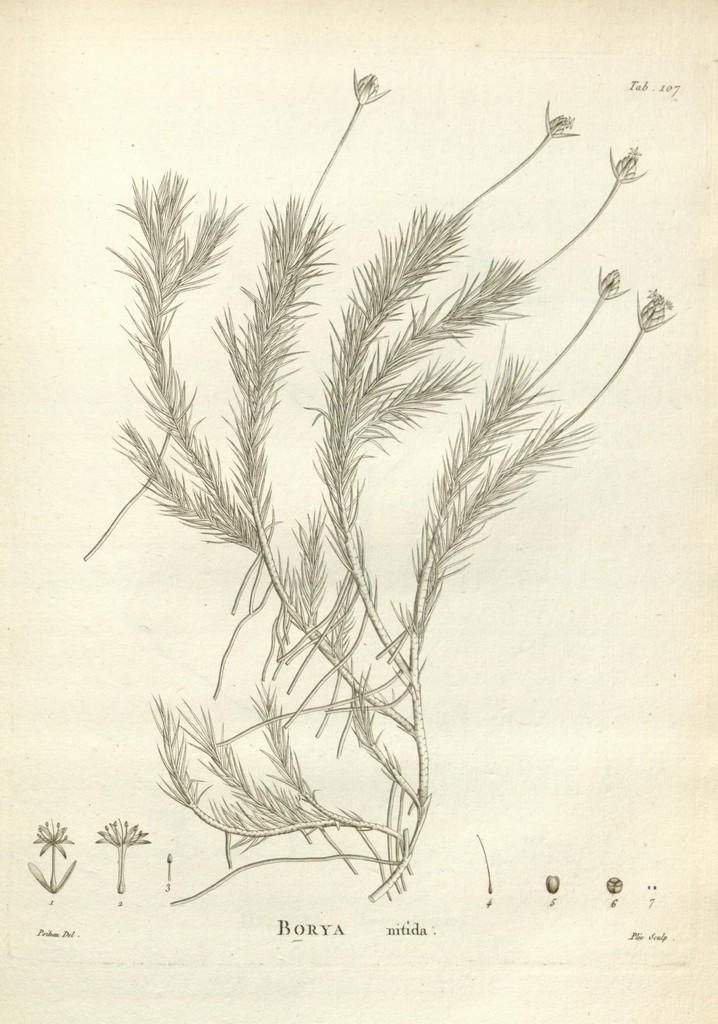What is depicted in the image? There is a sketch of a plant in the image. What is the medium of the sketch? The sketch is on a piece of paper. What additional information is present at the bottom of the image? There is text at the bottom of the image. What is the color of the background in the image? The background color is cream. What type of language is spoken by the wren in the image? There is no wren present in the image, so it is not possible to determine the language spoken by a wren. Is there any coal visible in the image? There is no coal present in the image. 